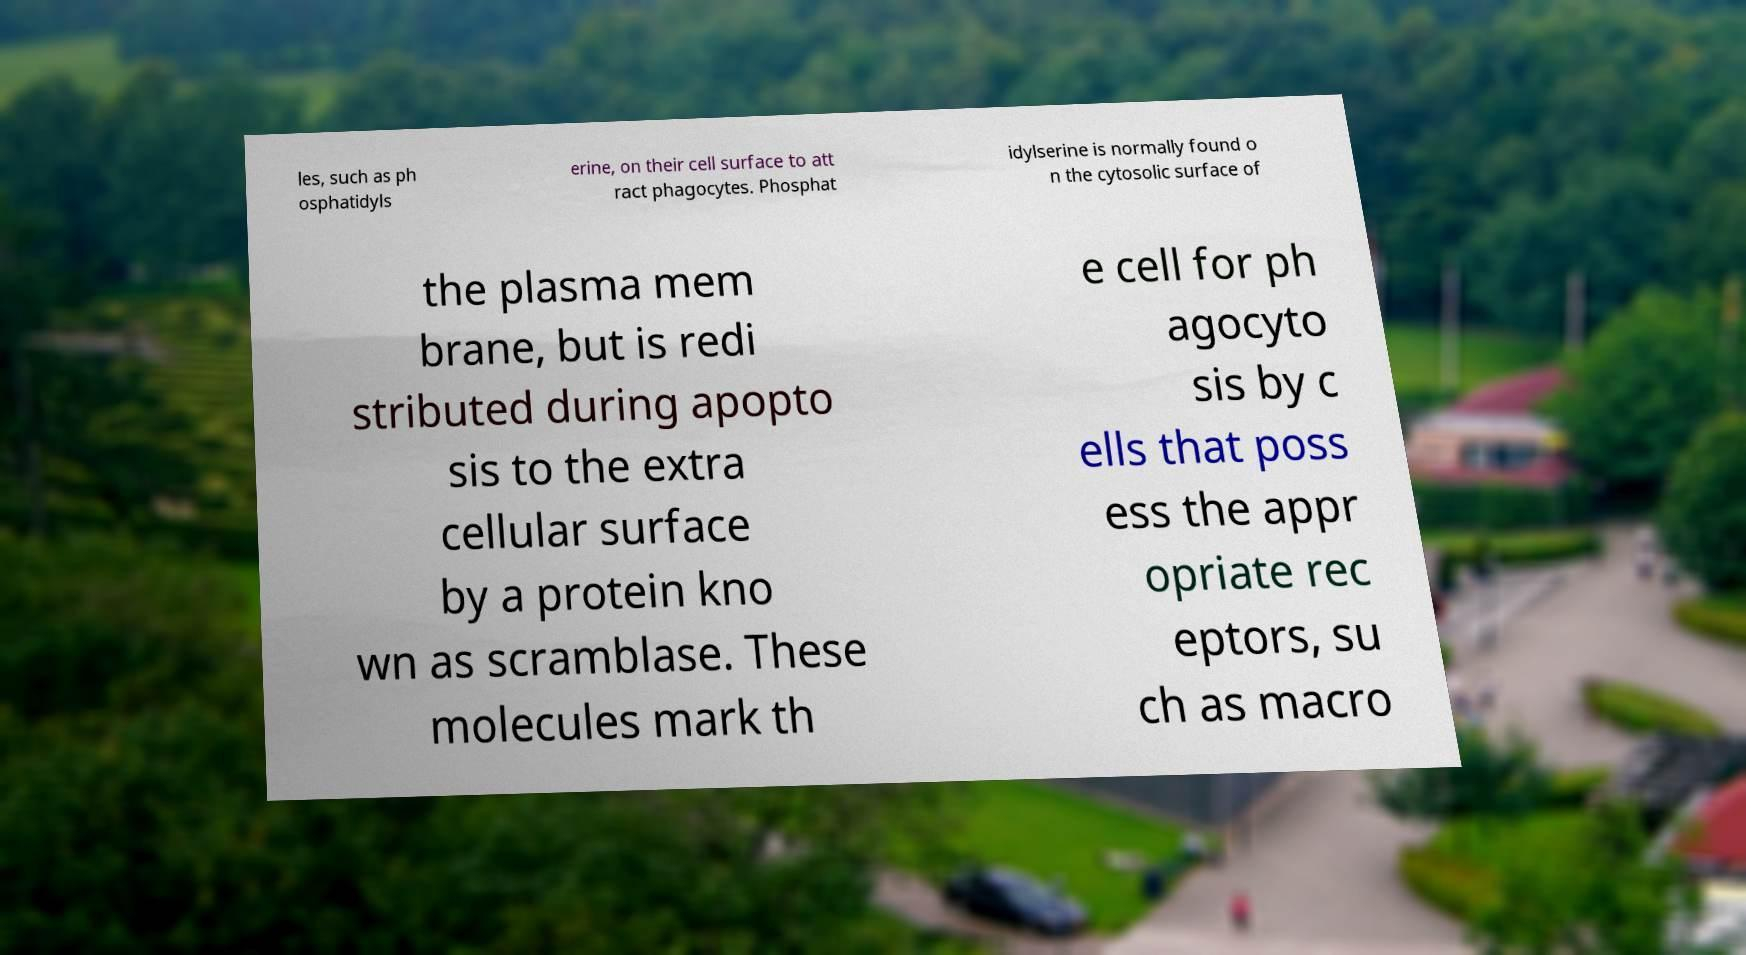For documentation purposes, I need the text within this image transcribed. Could you provide that? les, such as ph osphatidyls erine, on their cell surface to att ract phagocytes. Phosphat idylserine is normally found o n the cytosolic surface of the plasma mem brane, but is redi stributed during apopto sis to the extra cellular surface by a protein kno wn as scramblase. These molecules mark th e cell for ph agocyto sis by c ells that poss ess the appr opriate rec eptors, su ch as macro 